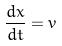Convert formula to latex. <formula><loc_0><loc_0><loc_500><loc_500>\frac { d x } { d t } = v</formula> 